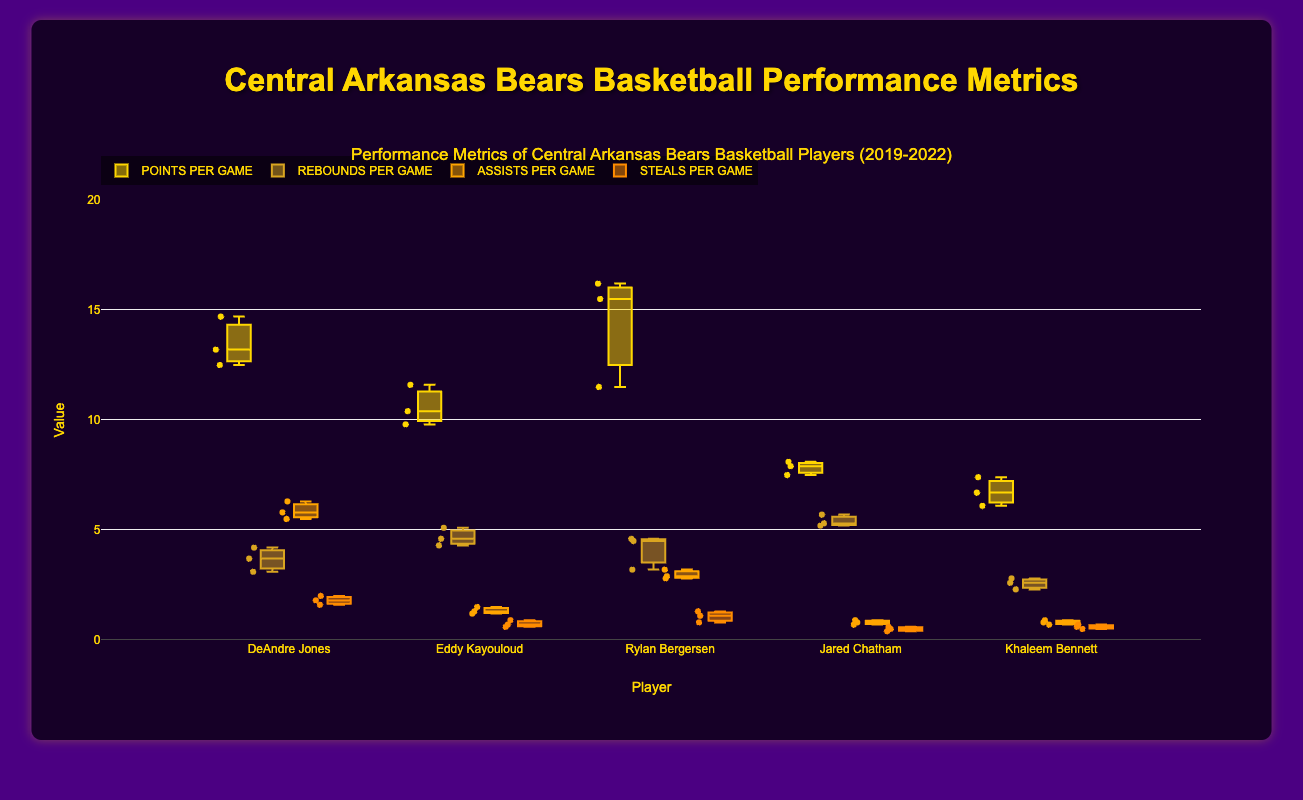What is the title of the figure? The title of the figure is usually located at the top center of the plot, providing a summary of what the plot represents. In this case, the title is clearly given as "Performance Metrics of Central Arkansas Bears Basketball Players (2019-2022)."
Answer: Performance Metrics of Central Arkansas Bears Basketball Players (2019-2022) Which player had the highest median points per game across all seasons? To find the player with the highest median points per game, look at the median line (middle line) within each box for each player's points per game. Based on the box plots, Rylan Bergersen's median line is consistently higher than the other players.
Answer: Rylan Bergersen Compare the assists per game for DeAndre Jones and Eddy Kayouloud. Who had higher variability in their performance? To compare the variability, we look at the spread (interquartile range) of the box plots for assists per game. DeAndre Jones appears to have a wider spread in assists per game compared to Eddy Kayouloud, indicating higher variability.
Answer: DeAndre Jones Which player had the lowest median steals per game? To determine the player with the lowest median steals per game, check the median line within each boxplot for steals per game. Jared Chatham's median line for steals per game is lower than other players.
Answer: Jared Chatham During the 2020-2021 season, which player had the highest points per game? To find this, pinpoint the data points for each player in the 2020-2021 season. Rylan Bergersen had the highest points per game in the 2020-2021 season, with an average of 15.5 points.
Answer: Rylan Bergersen How many players had a median rebounds per game greater than 4 in any season? Check the median lines of the box plots for rebounds per game. Both Eddy Kayouloud and Rylan Bergersen had median rebounds per game greater than 4 in one or more seasons.
Answer: 2 What is the median value of assists per game for Jared Chatham? Look at the median line inside Jared Chatham's box plots for assists per game across seasons. The median value appears to be around 0.8 assists per game.
Answer: 0.8 Compare the consistency of points per game for DeAndre Jones and Rylan Bergersen. Who is more consistent? To assess consistency, examine the spread (interquartile range) within the box plots for points per game. DeAndre Jones has a smaller spread, indicating more consistency compared to Rylan Bergersen.
Answer: DeAndre Jones Which metric shows the least amount of variability for all players combined? Look at the width of the box plots for each metric. The steals per game metric has the narrowest boxes for all players, indicating the least variability.
Answer: Steals per game 